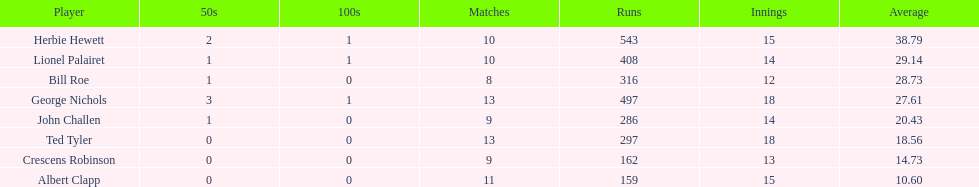How many innings did bill and ted have in total? 30. 